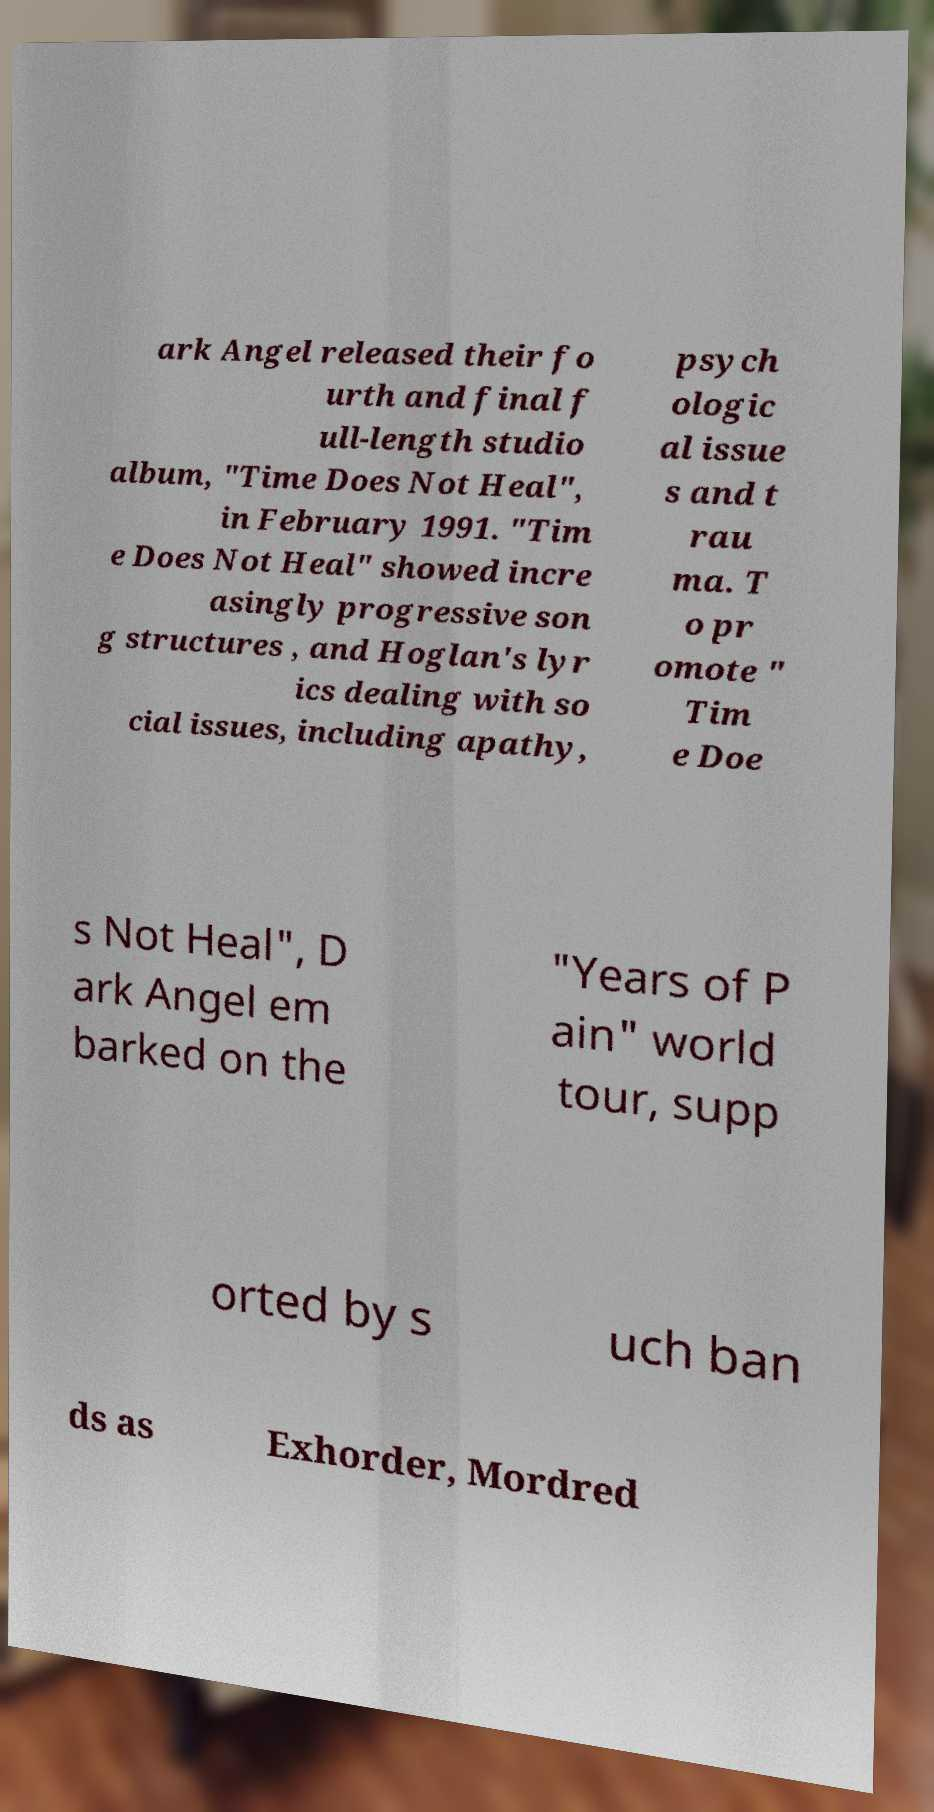I need the written content from this picture converted into text. Can you do that? ark Angel released their fo urth and final f ull-length studio album, "Time Does Not Heal", in February 1991. "Tim e Does Not Heal" showed incre asingly progressive son g structures , and Hoglan's lyr ics dealing with so cial issues, including apathy, psych ologic al issue s and t rau ma. T o pr omote " Tim e Doe s Not Heal", D ark Angel em barked on the "Years of P ain" world tour, supp orted by s uch ban ds as Exhorder, Mordred 